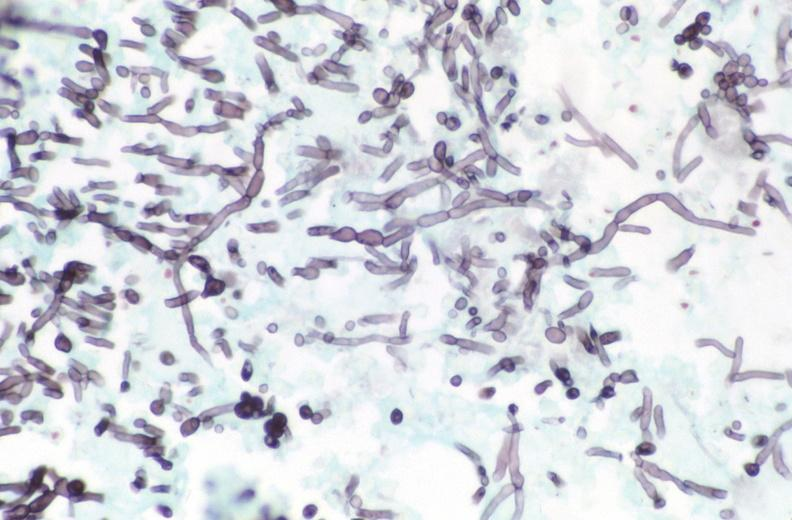does this image show esohagus, candida?
Answer the question using a single word or phrase. Yes 